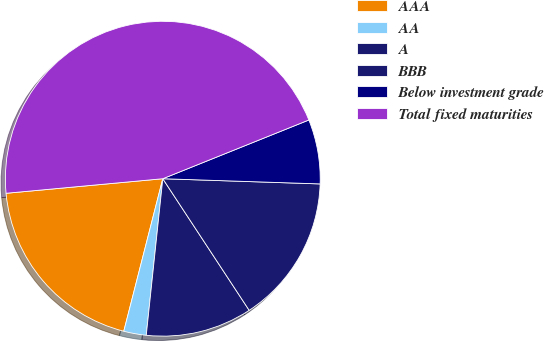<chart> <loc_0><loc_0><loc_500><loc_500><pie_chart><fcel>AAA<fcel>AA<fcel>A<fcel>BBB<fcel>Below investment grade<fcel>Total fixed maturities<nl><fcel>19.54%<fcel>2.31%<fcel>10.92%<fcel>15.23%<fcel>6.61%<fcel>45.39%<nl></chart> 